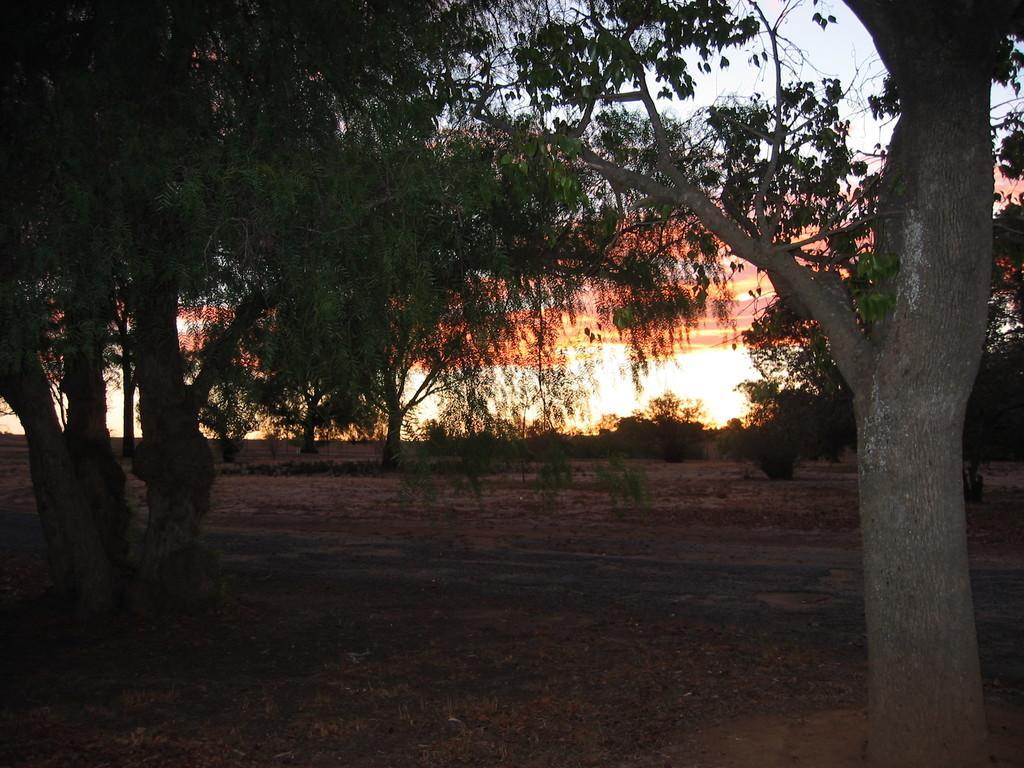In one or two sentences, can you explain what this image depicts? In this picture we can see trees, there is the sky in the background. 